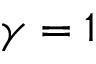<formula> <loc_0><loc_0><loc_500><loc_500>\gamma = 1</formula> 